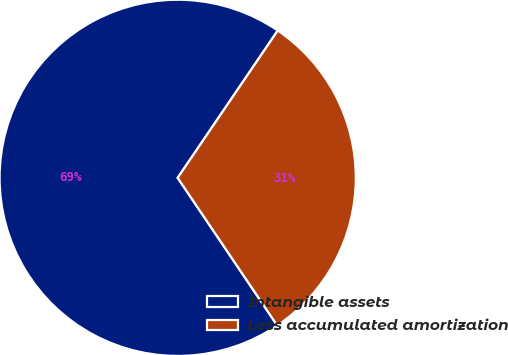<chart> <loc_0><loc_0><loc_500><loc_500><pie_chart><fcel>Intangible assets<fcel>Less accumulated amortization<nl><fcel>68.94%<fcel>31.06%<nl></chart> 